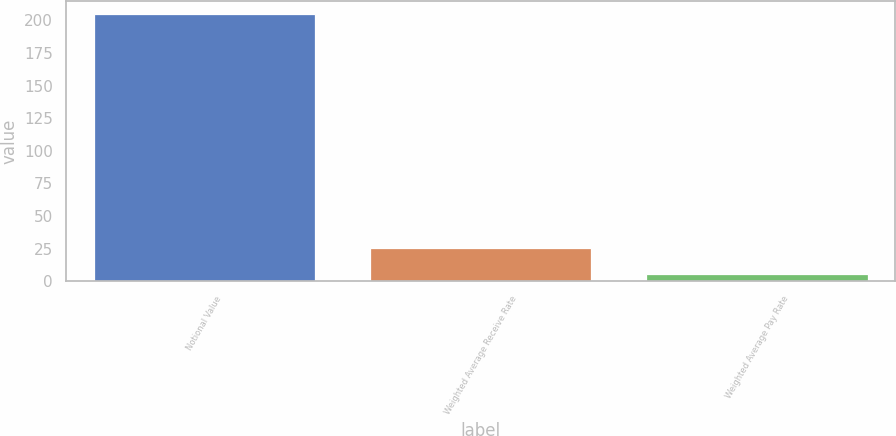<chart> <loc_0><loc_0><loc_500><loc_500><bar_chart><fcel>Notional Value<fcel>Weighted Average Receive Rate<fcel>Weighted Average Pay Rate<nl><fcel>205<fcel>25.32<fcel>5.36<nl></chart> 